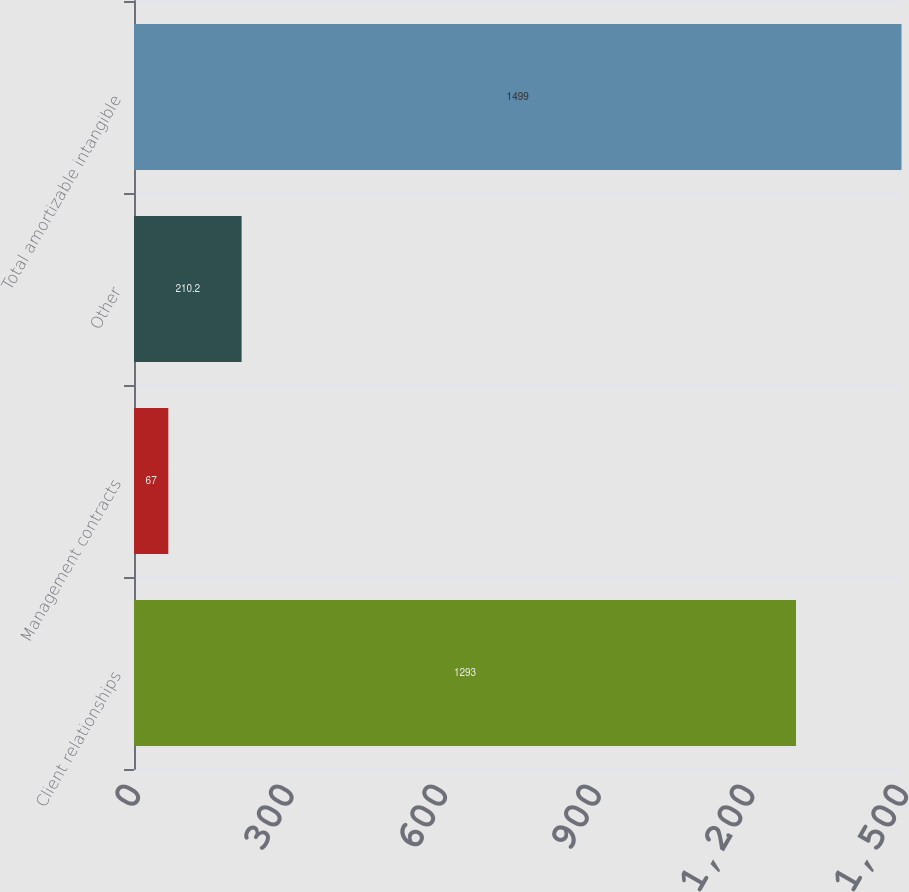Convert chart to OTSL. <chart><loc_0><loc_0><loc_500><loc_500><bar_chart><fcel>Client relationships<fcel>Management contracts<fcel>Other<fcel>Total amortizable intangible<nl><fcel>1293<fcel>67<fcel>210.2<fcel>1499<nl></chart> 